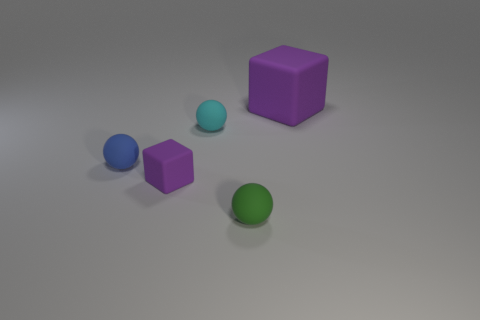Does the purple matte thing left of the green rubber object have the same size as the big thing?
Your answer should be very brief. No. How many cylinders are tiny green matte objects or big purple matte things?
Keep it short and to the point. 0. Are there fewer purple matte things than small yellow matte cubes?
Keep it short and to the point. No. What is the size of the object that is both right of the tiny cyan matte object and behind the small purple matte cube?
Offer a very short reply. Large. There is a purple thing that is left of the small matte sphere in front of the rubber sphere that is to the left of the small purple rubber object; how big is it?
Provide a succinct answer. Small. How many other objects are there of the same color as the large matte object?
Keep it short and to the point. 1. There is a matte sphere behind the blue matte sphere; is its color the same as the tiny matte cube?
Your answer should be very brief. No. How many things are large brown rubber balls or blue objects?
Provide a short and direct response. 1. There is a block that is behind the small rubber block; what color is it?
Ensure brevity in your answer.  Purple. Is the number of tiny rubber things that are left of the cyan object less than the number of small rubber objects?
Your answer should be very brief. Yes. 